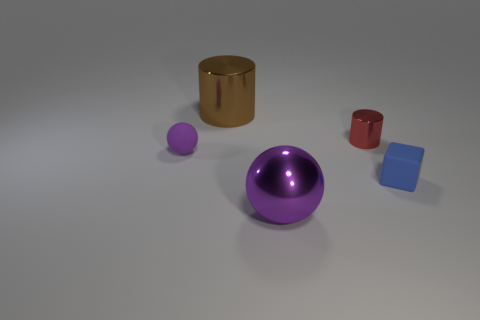There is another thing that is the same shape as the purple rubber object; what material is it?
Provide a succinct answer. Metal. The small blue thing has what shape?
Your response must be concise. Cube. What is the material of the thing that is to the right of the big brown metal cylinder and behind the matte cube?
Give a very brief answer. Metal. There is a large purple object that is made of the same material as the tiny red cylinder; what shape is it?
Provide a succinct answer. Sphere. There is a brown cylinder that is the same material as the large purple ball; what size is it?
Your answer should be compact. Large. What is the shape of the object that is in front of the tiny matte sphere and to the left of the tiny red thing?
Your answer should be compact. Sphere. There is a metallic thing in front of the thing that is right of the tiny red shiny thing; how big is it?
Offer a terse response. Large. How many other objects are the same color as the small cylinder?
Your answer should be compact. 0. What is the material of the small cylinder?
Your response must be concise. Metal. Are there any big brown rubber cubes?
Your answer should be very brief. No. 